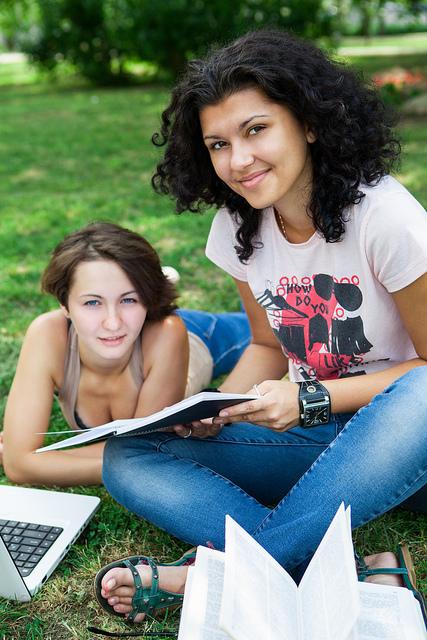Does the girl on the left have noticeable cleavage?
Be succinct. Yes. Is the girl sitting up wearing a purple hat?
Be succinct. No. Do both girls have parts in their hair?
Short answer required. Yes. 